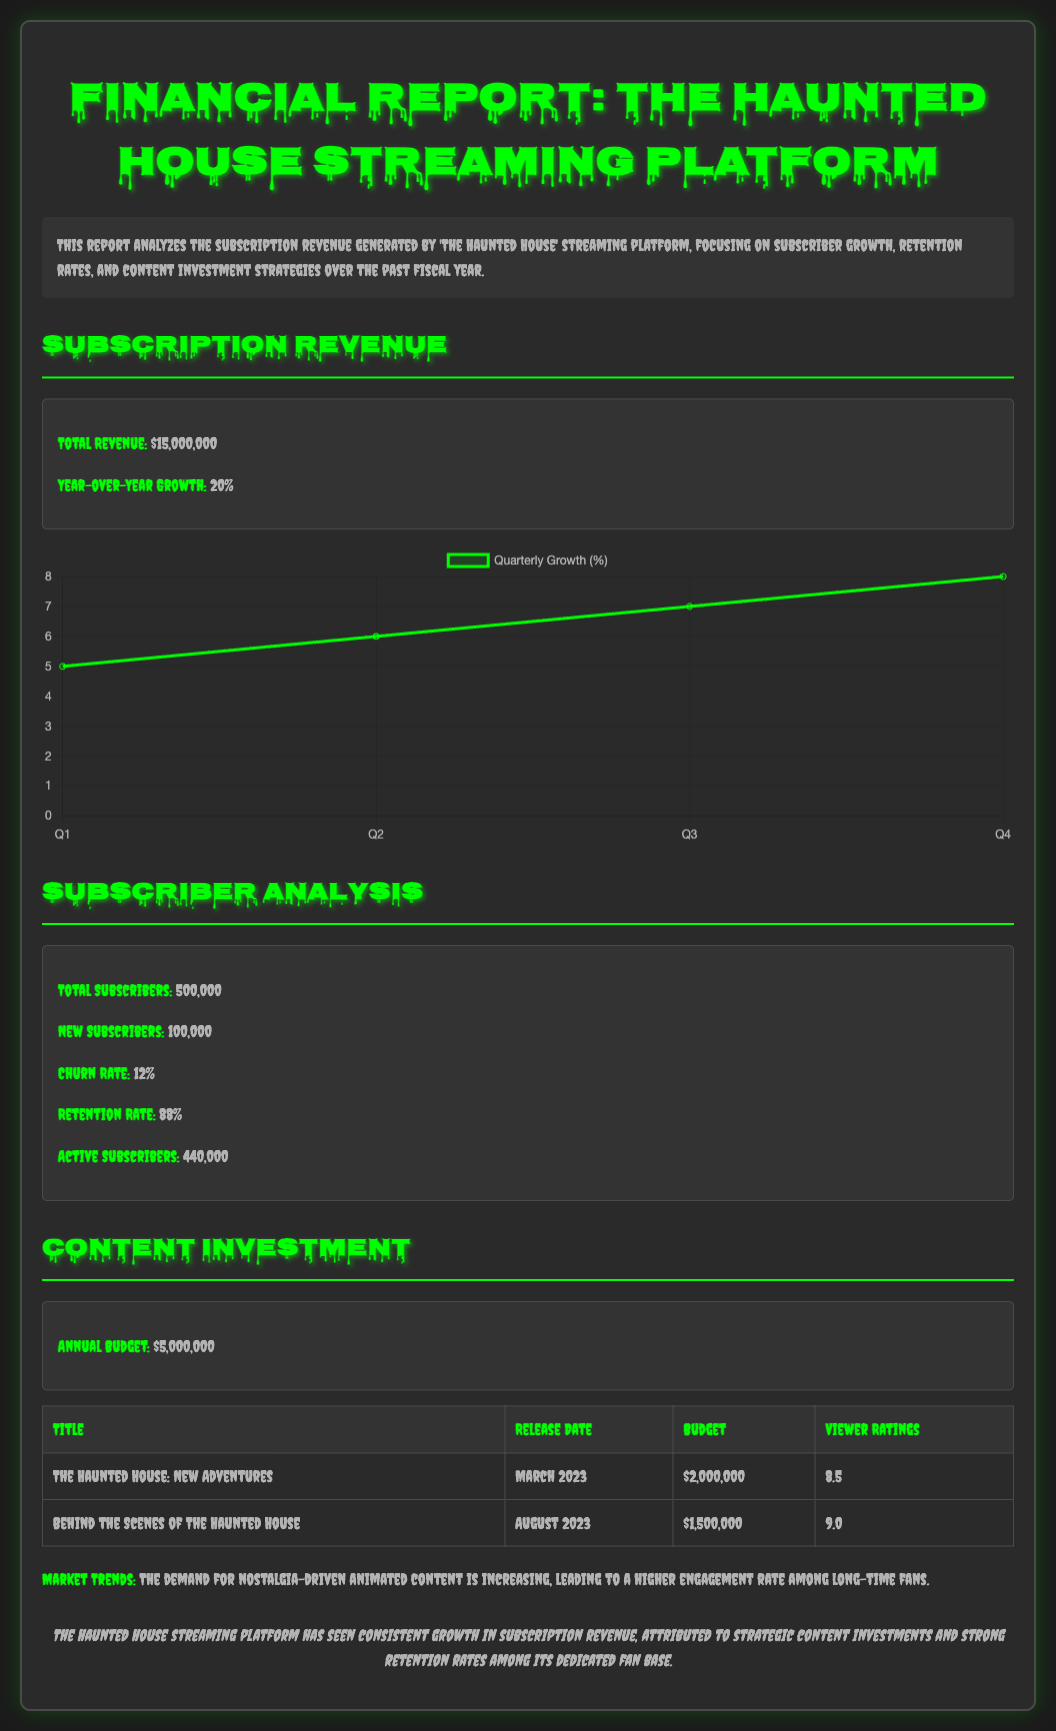What is the total revenue? The total revenue is stated in the document as $15,000,000.
Answer: $15,000,000 What is the year-over-year growth percentage? The document specifies the year-over-year growth as 20%.
Answer: 20% How many total subscribers does the platform have? The total number of subscribers is noted as 500,000.
Answer: 500,000 What is the churn rate? The document indicates the churn rate as 12%.
Answer: 12% What is the retention rate? The retention rate is provided in the report as 88%.
Answer: 88% What is the annual budget for content investment? The annual budget for content investment is mentioned as $5,000,000.
Answer: $5,000,000 Which title had the highest viewer ratings? The title "Behind the Scenes of The Haunted House" is shown to have the highest viewer rating of 9.0.
Answer: 9.0 What is the release date of "The Haunted House: New Adventures"? The document lists the release date of "The Haunted House: New Adventures" as March 2023.
Answer: March 2023 What trend is mentioned regarding market demand? The document mentions an increasing demand for nostalgia-driven animated content.
Answer: Nostalgia-driven animated content 